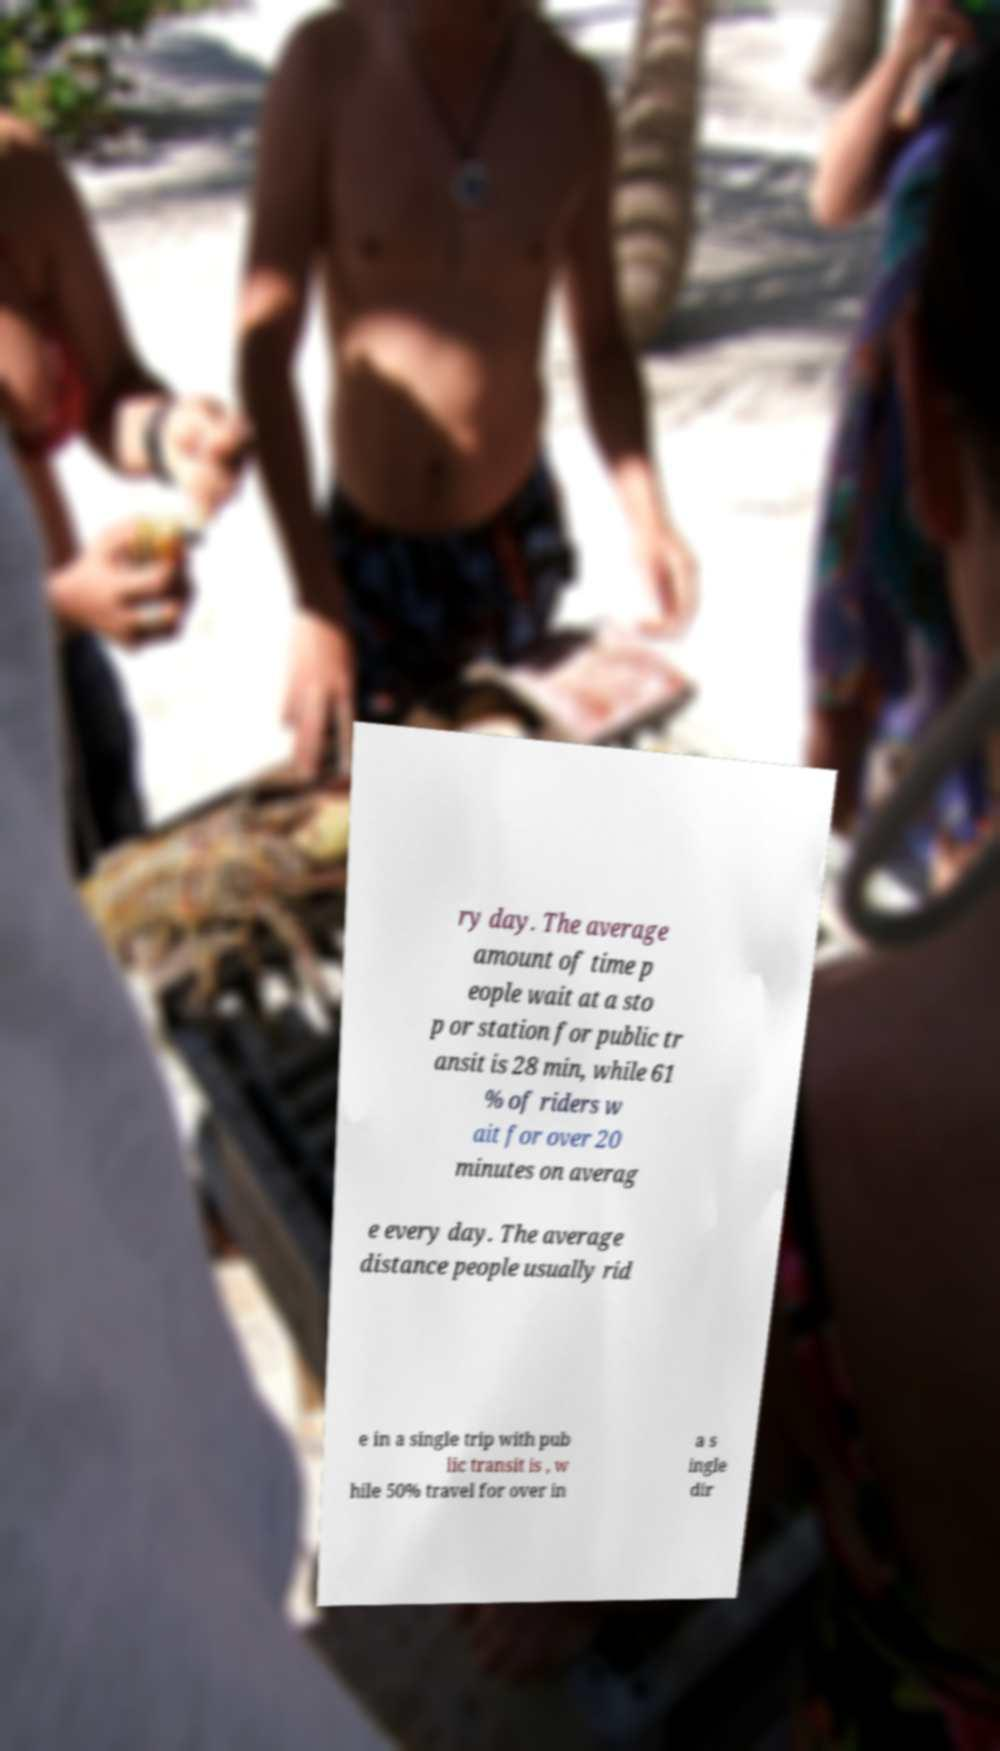Could you extract and type out the text from this image? ry day. The average amount of time p eople wait at a sto p or station for public tr ansit is 28 min, while 61 % of riders w ait for over 20 minutes on averag e every day. The average distance people usually rid e in a single trip with pub lic transit is , w hile 50% travel for over in a s ingle dir 